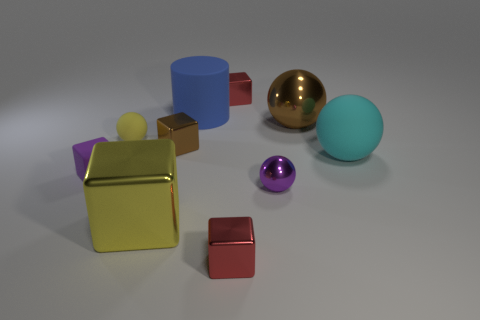Looking at the composition of the objects, what kind of mood or artistic concept could this image represent? The image's composition, with its clean background and orderly arrangement of shapes, conveys a sense of minimalism and balance. The variety in shape and color could symbolize diversity and unity. Artistically, it might represent an exploration of geometry, color theory, and the interplay of light and texture. The mood instilled is one of calm and contemplative order, inviting the viewer to appreciate the simplicity of form and careful positioning of the objects. 